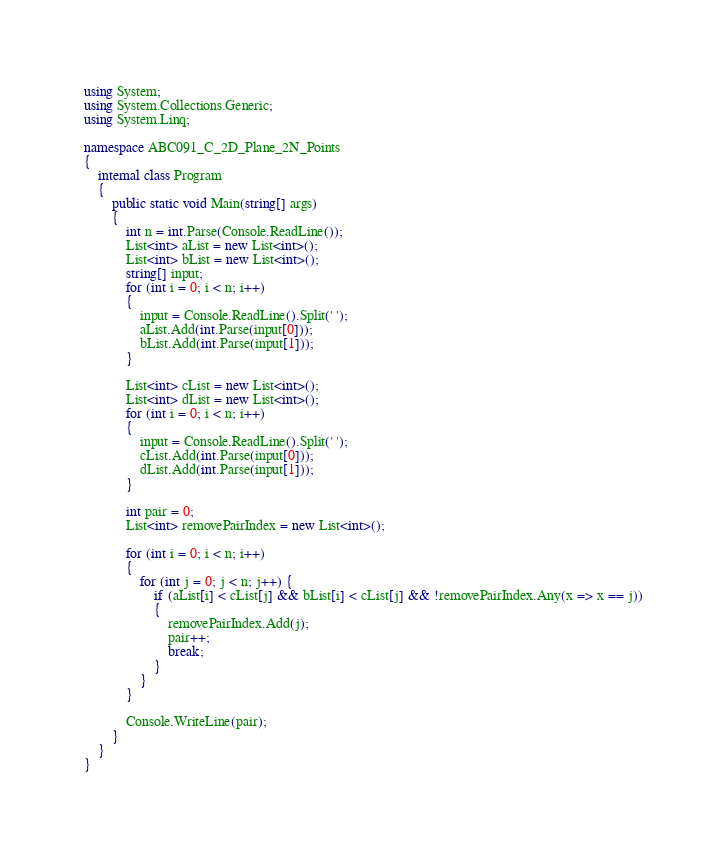Convert code to text. <code><loc_0><loc_0><loc_500><loc_500><_C#_>using System;
using System.Collections.Generic;
using System.Linq;

namespace ABC091_C_2D_Plane_2N_Points
{
	internal class Program
	{
		public static void Main(string[] args)
		{
			int n = int.Parse(Console.ReadLine());
			List<int> aList = new List<int>();
			List<int> bList = new List<int>();
			string[] input;
			for (int i = 0; i < n; i++)
			{
				input = Console.ReadLine().Split(' ');
				aList.Add(int.Parse(input[0]));
				bList.Add(int.Parse(input[1]));
			}
			
			List<int> cList = new List<int>();
			List<int> dList = new List<int>();
			for (int i = 0; i < n; i++)
			{
				input = Console.ReadLine().Split(' ');
				cList.Add(int.Parse(input[0]));
				dList.Add(int.Parse(input[1]));
			}

			int pair = 0;
			List<int> removePairIndex = new List<int>();
			
			for (int i = 0; i < n; i++)
			{
				for (int j = 0; j < n; j++) {
					if (aList[i] < cList[j] && bList[i] < cList[j] && !removePairIndex.Any(x => x == j))
					{
						removePairIndex.Add(j);
						pair++;
						break;
					}
				}
			}
			
			Console.WriteLine(pair);
		}
	}
}</code> 